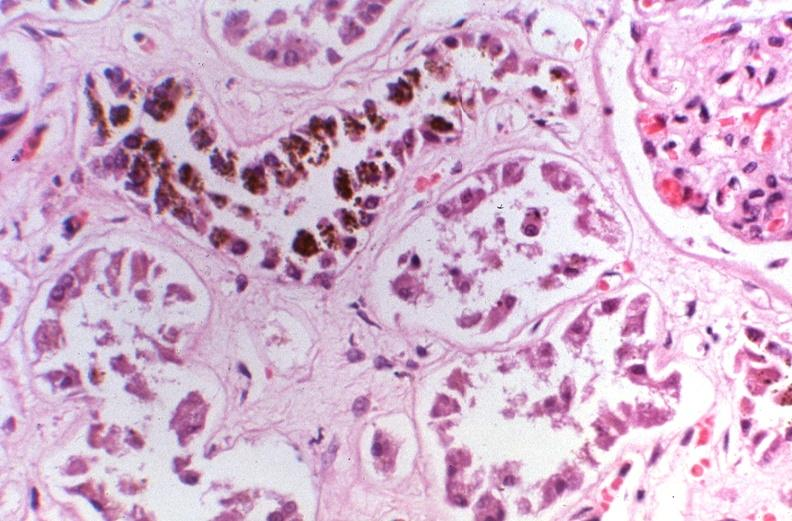does this image show kidney, hemochromatosis?
Answer the question using a single word or phrase. Yes 